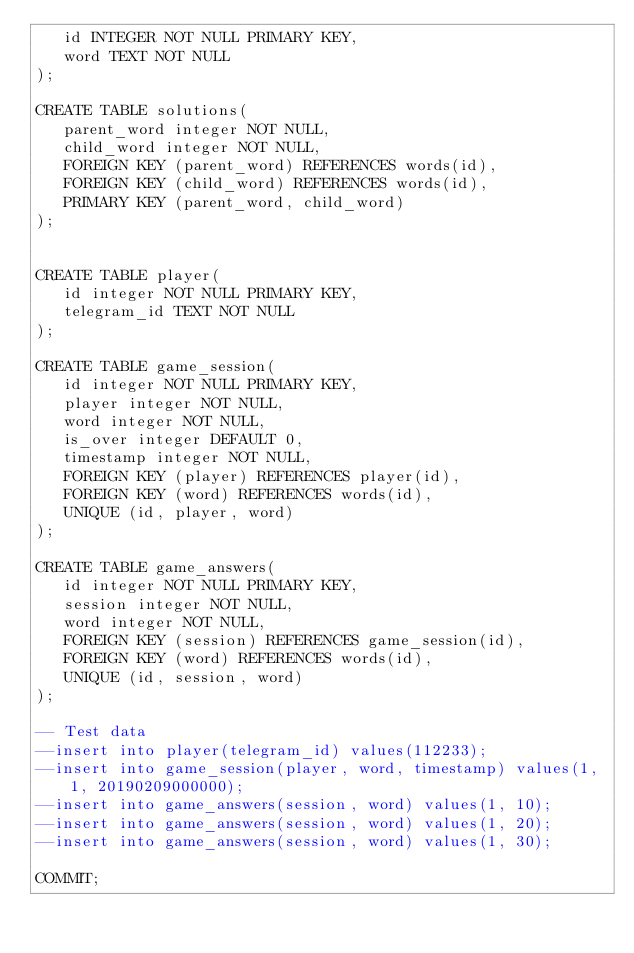Convert code to text. <code><loc_0><loc_0><loc_500><loc_500><_SQL_>   id INTEGER NOT NULL PRIMARY KEY,
   word TEXT NOT NULL
);

CREATE TABLE solutions(
   parent_word integer NOT NULL,
   child_word integer NOT NULL,
   FOREIGN KEY (parent_word) REFERENCES words(id),
   FOREIGN KEY (child_word) REFERENCES words(id),
   PRIMARY KEY (parent_word, child_word)
);


CREATE TABLE player(
   id integer NOT NULL PRIMARY KEY,
   telegram_id TEXT NOT NULL
);

CREATE TABLE game_session(
   id integer NOT NULL PRIMARY KEY,
   player integer NOT NULL,
   word integer NOT NULL,
   is_over integer DEFAULT 0,
   timestamp integer NOT NULL,
   FOREIGN KEY (player) REFERENCES player(id),
   FOREIGN KEY (word) REFERENCES words(id),
   UNIQUE (id, player, word)
);

CREATE TABLE game_answers(
   id integer NOT NULL PRIMARY KEY,
   session integer NOT NULL,
   word integer NOT NULL,
   FOREIGN KEY (session) REFERENCES game_session(id),
   FOREIGN KEY (word) REFERENCES words(id),
   UNIQUE (id, session, word)
);

-- Test data
--insert into player(telegram_id) values(112233);
--insert into game_session(player, word, timestamp) values(1, 1, 20190209000000);
--insert into game_answers(session, word) values(1, 10);
--insert into game_answers(session, word) values(1, 20);
--insert into game_answers(session, word) values(1, 30);

COMMIT;
</code> 